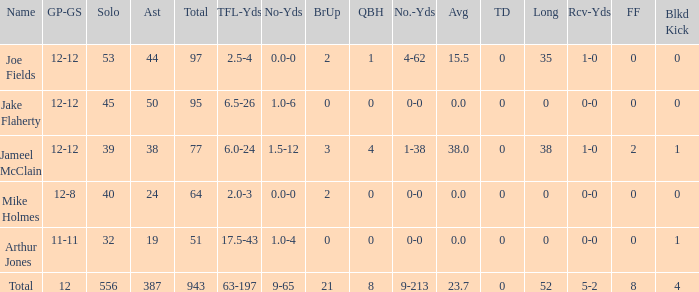What is the overall brup for the group? 21.0. 